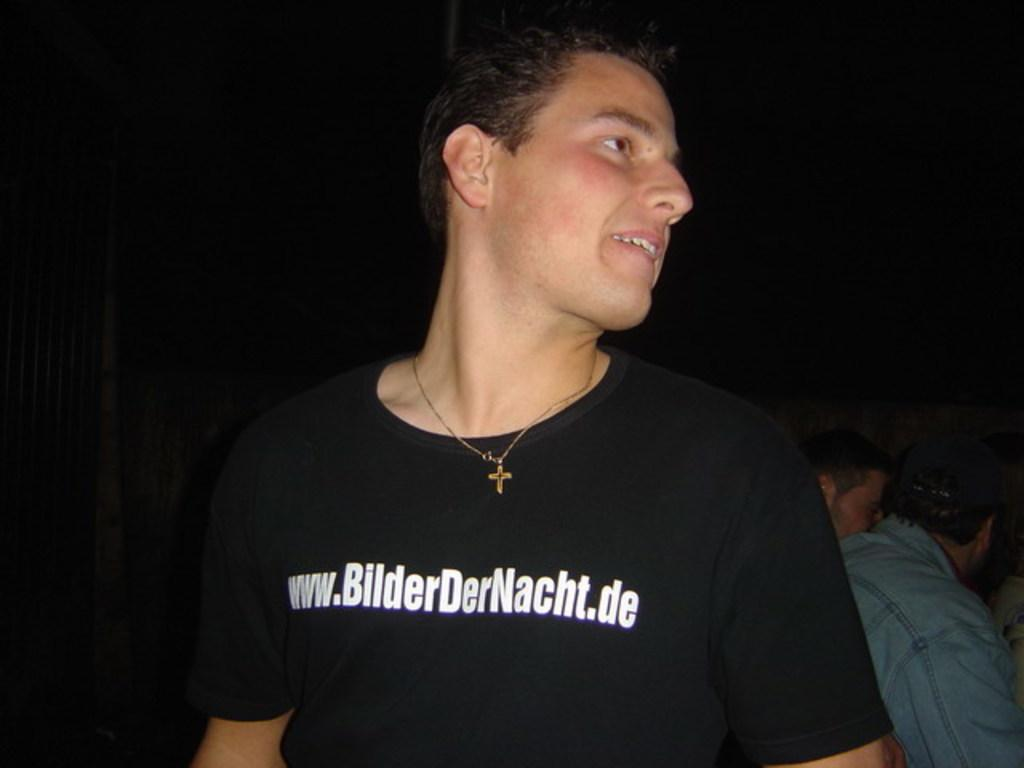Who is the main subject in the image? There is a person in the center of the image. Can you describe the surrounding environment in the image? In the background, there are persons sitting. What type of shoe is the person wearing in the image? There is no information about the person's shoes in the image, so it cannot be determined. 